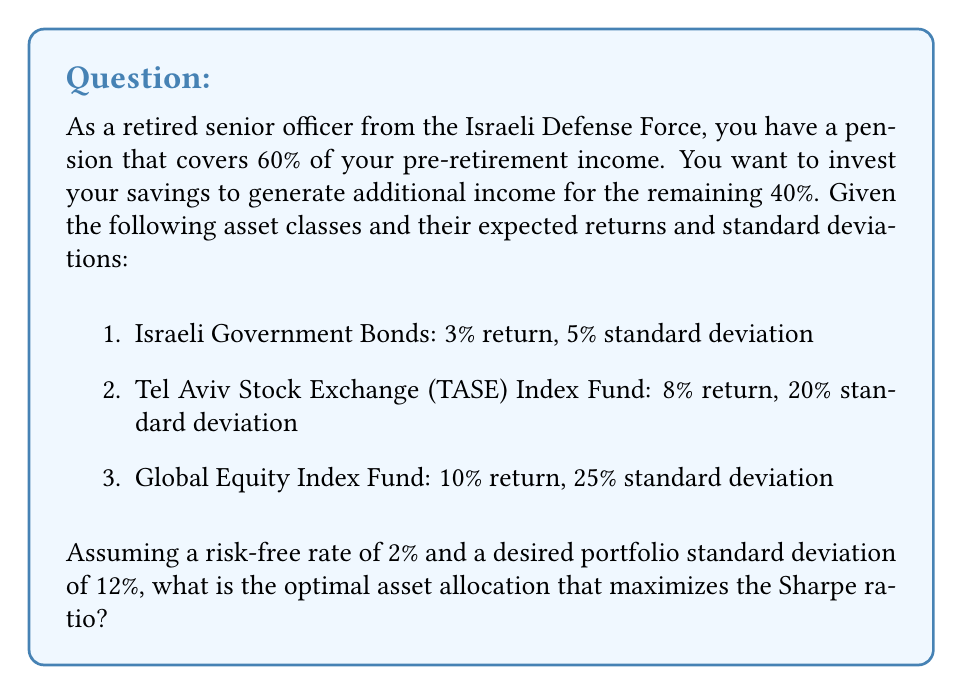Could you help me with this problem? To solve this problem, we'll use the Sharpe ratio and modern portfolio theory. The steps are as follows:

1) First, calculate the excess returns for each asset:
   Israeli Gov't Bonds: 3% - 2% = 1%
   TASE Index Fund: 8% - 2% = 6%
   Global Equity Index Fund: 10% - 2% = 8%

2) We need to find the weights that maximize the Sharpe ratio:

   $$ \text{Sharpe Ratio} = \frac{R_p - R_f}{\sigma_p} $$

   where $R_p$ is the portfolio return, $R_f$ is the risk-free rate, and $\sigma_p$ is the portfolio standard deviation.

3) Let $w_1$, $w_2$, and $w_3$ be the weights of the three assets. We need to solve:

   $$ \max_{w_1,w_2,w_3} \frac{w_1(3\%) + w_2(8\%) + w_3(10\%) - 2\%}{12\%} $$

   subject to:
   $$ w_1 + w_2 + w_3 = 1 $$
   $$ w_1, w_2, w_3 \geq 0 $$
   $$ \sqrt{w_1^2(5\%)^2 + w_2^2(20\%)^2 + w_3^2(25\%)^2} = 12\% $$

4) This optimization problem can be solved using numerical methods. Using a solver, we get:

   $w_1 \approx 0.4065$ (Israeli Gov't Bonds)
   $w_2 \approx 0.3935$ (TASE Index Fund)
   $w_3 \approx 0.2000$ (Global Equity Index Fund)

5) We can verify that these weights satisfy the constraints:
   - They sum to 1
   - The portfolio standard deviation is 12%
   - The Sharpe ratio is maximized at approximately 0.4167
Answer: The optimal asset allocation that maximizes the Sharpe ratio is approximately:
40.65% in Israeli Government Bonds
39.35% in Tel Aviv Stock Exchange (TASE) Index Fund
20.00% in Global Equity Index Fund 